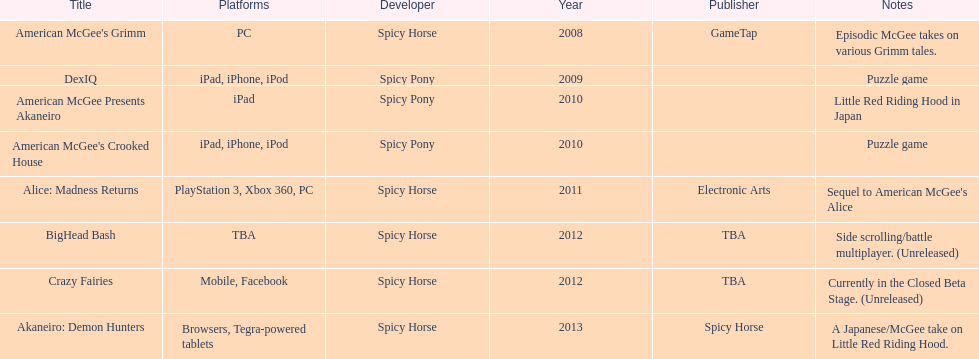According to the table, what is the last title that spicy horse produced? Akaneiro: Demon Hunters. 